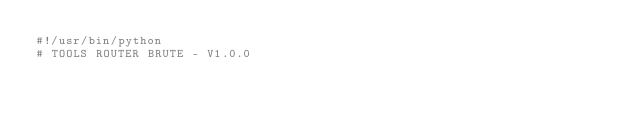<code> <loc_0><loc_0><loc_500><loc_500><_Python_>#!/usr/bin/python
# TOOLS ROUTER BRUTE - V1.0.0</code> 